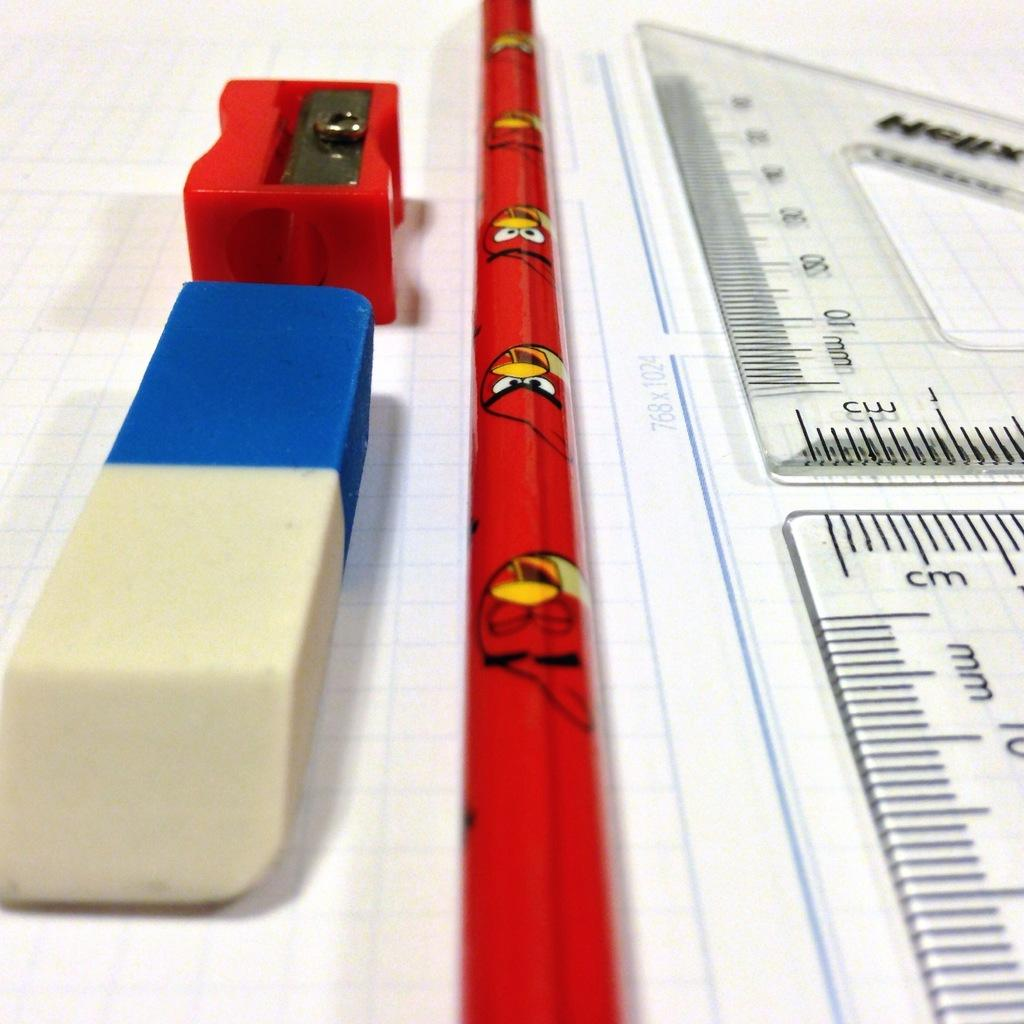<image>
Render a clear and concise summary of the photo. the letters cm that are on a ruler 